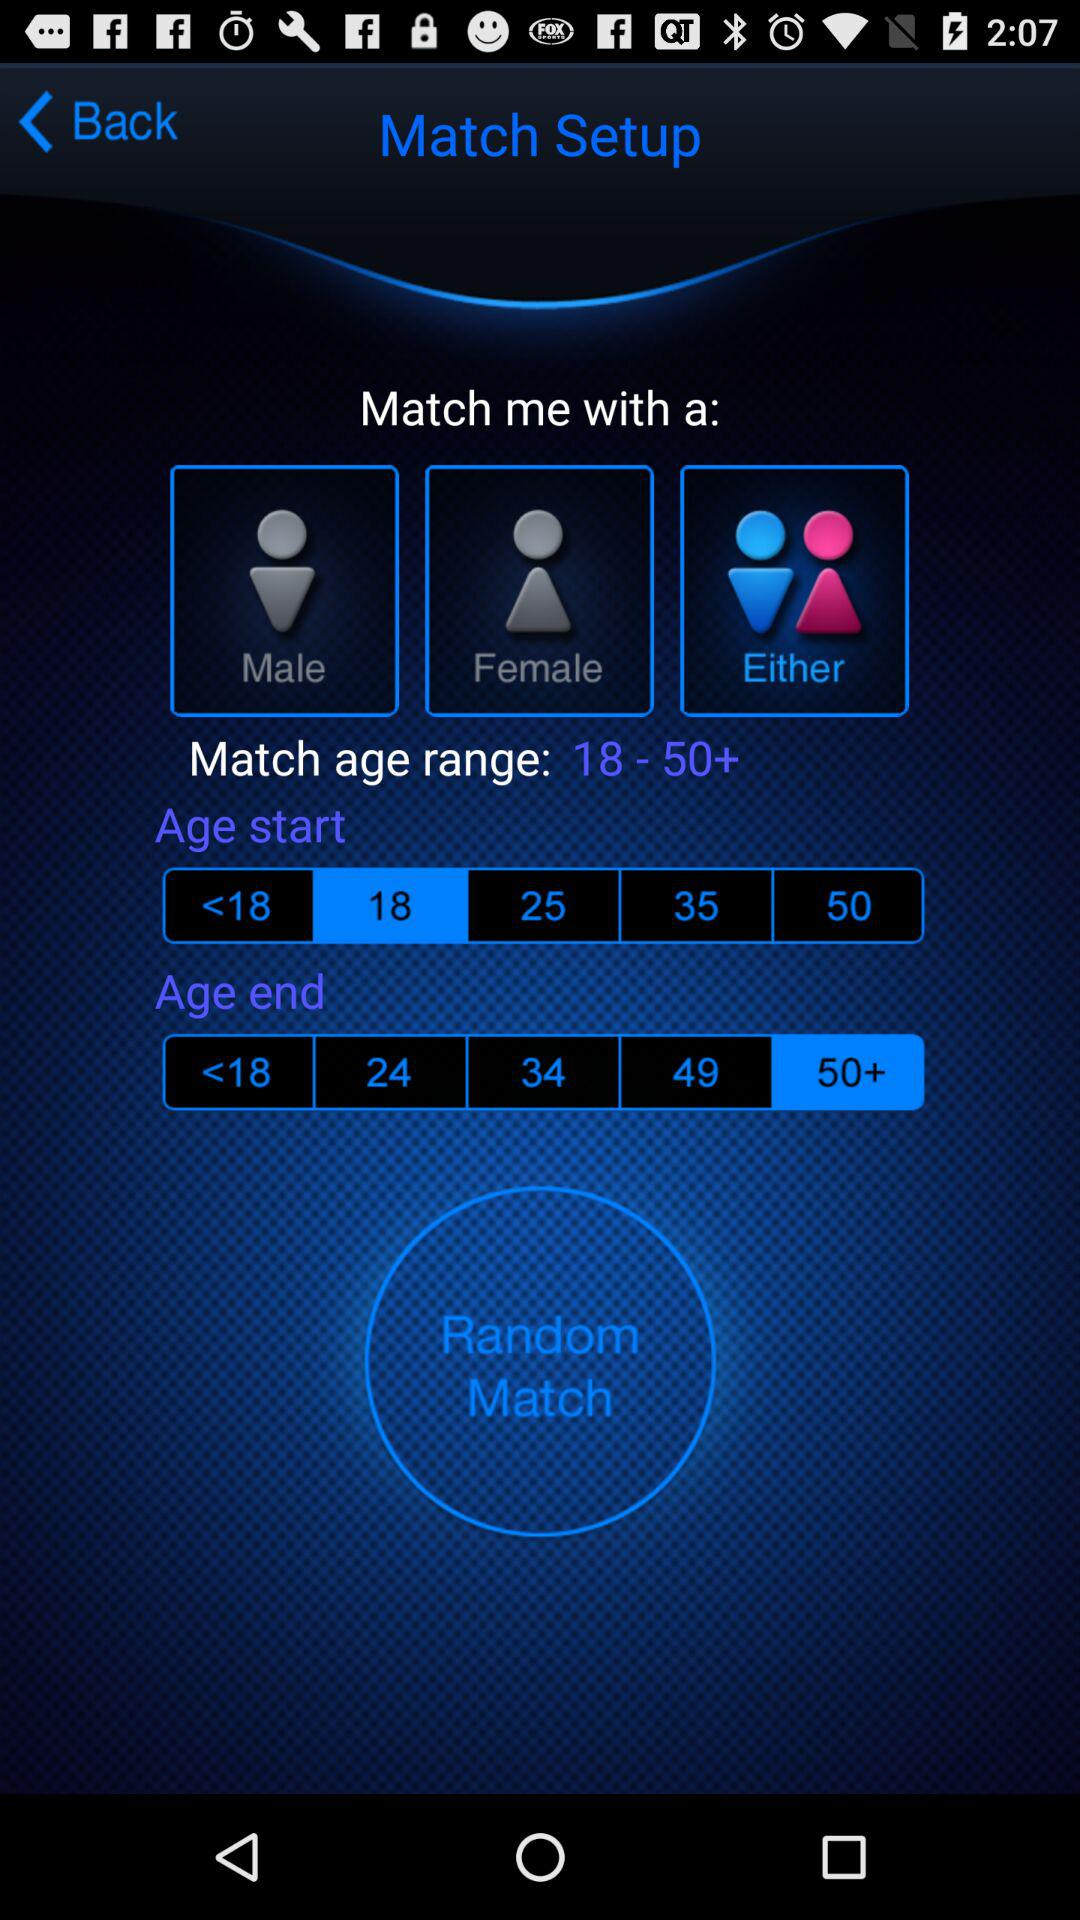How many age options are there for the age end range?
Answer the question using a single word or phrase. 5 